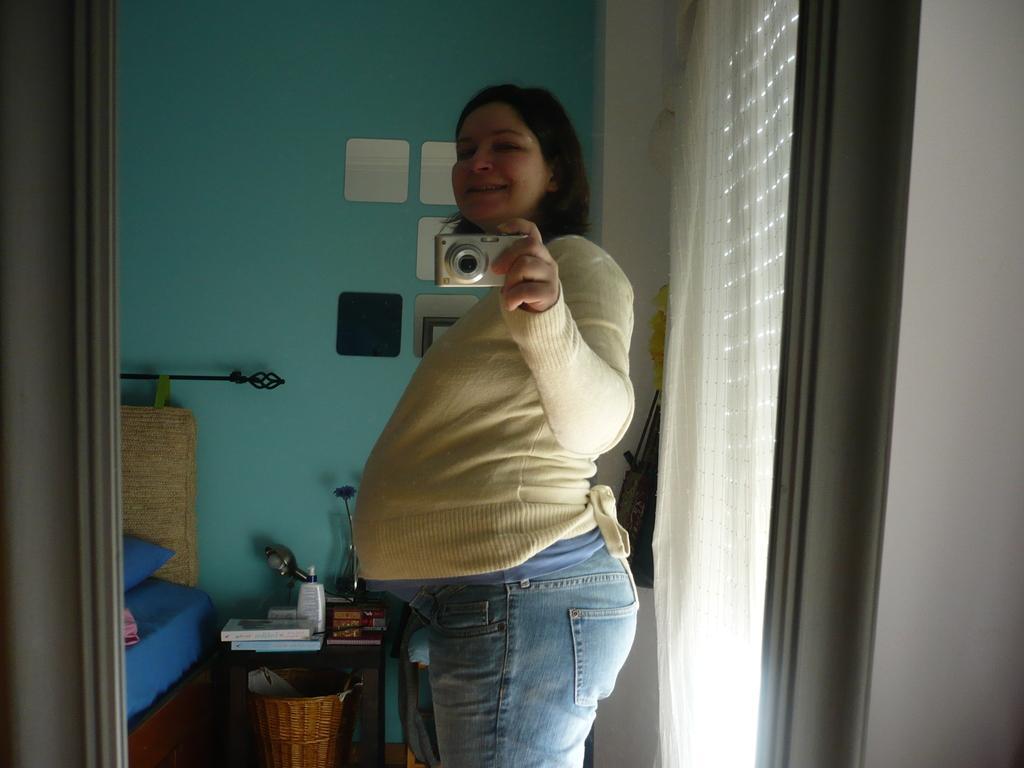Could you give a brief overview of what you see in this image? In this image there is one woman who is standing and she is holding a camera and she is smiling on the right side there is one wall beside that wall there is one window and curtain on the top of the image there is one wall on the left side of the image there is one curtain and in the bottom of the image there is one table beside that table one bed is there on that table there are some books and light are there and under that table there is one dustbin. 